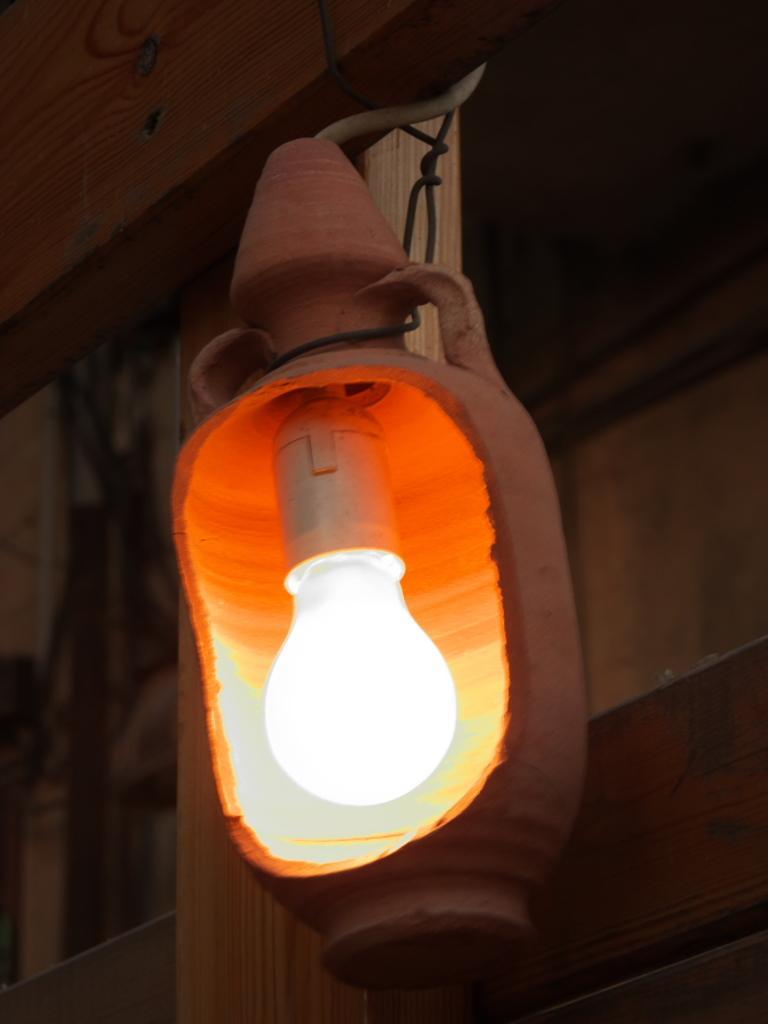Can you describe this image briefly? Here we can see a blown bulb. 